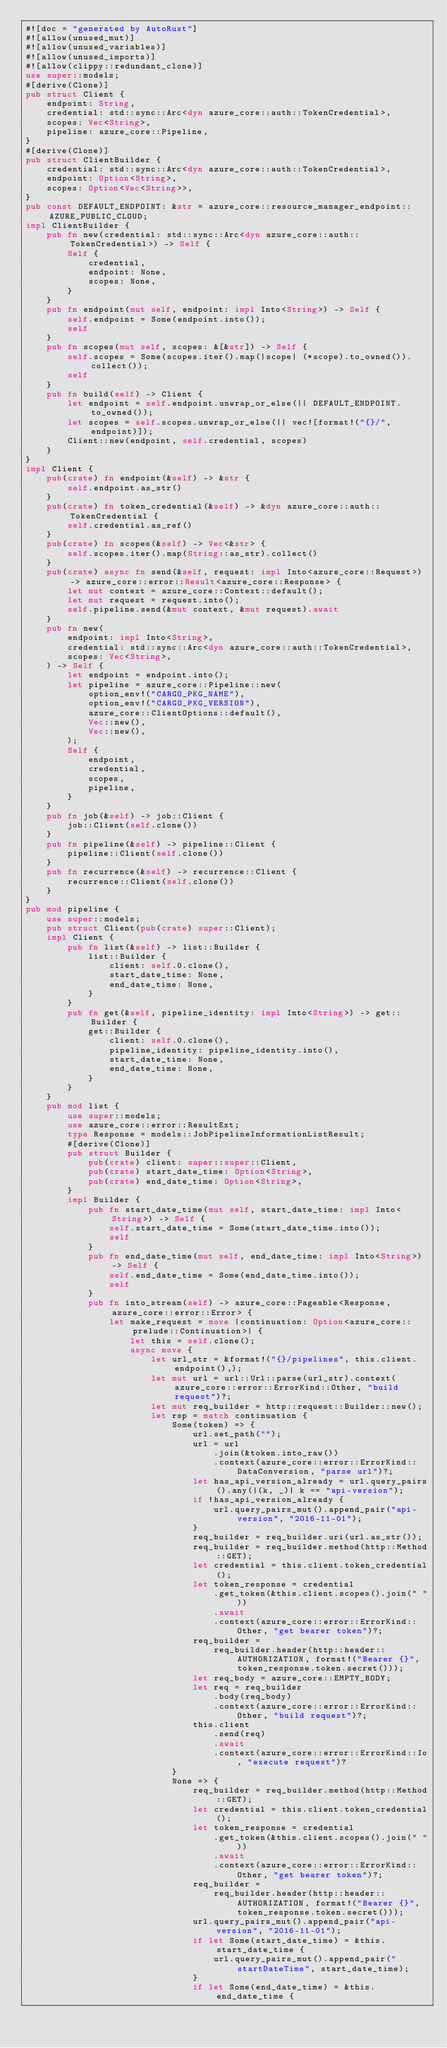<code> <loc_0><loc_0><loc_500><loc_500><_Rust_>#![doc = "generated by AutoRust"]
#![allow(unused_mut)]
#![allow(unused_variables)]
#![allow(unused_imports)]
#![allow(clippy::redundant_clone)]
use super::models;
#[derive(Clone)]
pub struct Client {
    endpoint: String,
    credential: std::sync::Arc<dyn azure_core::auth::TokenCredential>,
    scopes: Vec<String>,
    pipeline: azure_core::Pipeline,
}
#[derive(Clone)]
pub struct ClientBuilder {
    credential: std::sync::Arc<dyn azure_core::auth::TokenCredential>,
    endpoint: Option<String>,
    scopes: Option<Vec<String>>,
}
pub const DEFAULT_ENDPOINT: &str = azure_core::resource_manager_endpoint::AZURE_PUBLIC_CLOUD;
impl ClientBuilder {
    pub fn new(credential: std::sync::Arc<dyn azure_core::auth::TokenCredential>) -> Self {
        Self {
            credential,
            endpoint: None,
            scopes: None,
        }
    }
    pub fn endpoint(mut self, endpoint: impl Into<String>) -> Self {
        self.endpoint = Some(endpoint.into());
        self
    }
    pub fn scopes(mut self, scopes: &[&str]) -> Self {
        self.scopes = Some(scopes.iter().map(|scope| (*scope).to_owned()).collect());
        self
    }
    pub fn build(self) -> Client {
        let endpoint = self.endpoint.unwrap_or_else(|| DEFAULT_ENDPOINT.to_owned());
        let scopes = self.scopes.unwrap_or_else(|| vec![format!("{}/", endpoint)]);
        Client::new(endpoint, self.credential, scopes)
    }
}
impl Client {
    pub(crate) fn endpoint(&self) -> &str {
        self.endpoint.as_str()
    }
    pub(crate) fn token_credential(&self) -> &dyn azure_core::auth::TokenCredential {
        self.credential.as_ref()
    }
    pub(crate) fn scopes(&self) -> Vec<&str> {
        self.scopes.iter().map(String::as_str).collect()
    }
    pub(crate) async fn send(&self, request: impl Into<azure_core::Request>) -> azure_core::error::Result<azure_core::Response> {
        let mut context = azure_core::Context::default();
        let mut request = request.into();
        self.pipeline.send(&mut context, &mut request).await
    }
    pub fn new(
        endpoint: impl Into<String>,
        credential: std::sync::Arc<dyn azure_core::auth::TokenCredential>,
        scopes: Vec<String>,
    ) -> Self {
        let endpoint = endpoint.into();
        let pipeline = azure_core::Pipeline::new(
            option_env!("CARGO_PKG_NAME"),
            option_env!("CARGO_PKG_VERSION"),
            azure_core::ClientOptions::default(),
            Vec::new(),
            Vec::new(),
        );
        Self {
            endpoint,
            credential,
            scopes,
            pipeline,
        }
    }
    pub fn job(&self) -> job::Client {
        job::Client(self.clone())
    }
    pub fn pipeline(&self) -> pipeline::Client {
        pipeline::Client(self.clone())
    }
    pub fn recurrence(&self) -> recurrence::Client {
        recurrence::Client(self.clone())
    }
}
pub mod pipeline {
    use super::models;
    pub struct Client(pub(crate) super::Client);
    impl Client {
        pub fn list(&self) -> list::Builder {
            list::Builder {
                client: self.0.clone(),
                start_date_time: None,
                end_date_time: None,
            }
        }
        pub fn get(&self, pipeline_identity: impl Into<String>) -> get::Builder {
            get::Builder {
                client: self.0.clone(),
                pipeline_identity: pipeline_identity.into(),
                start_date_time: None,
                end_date_time: None,
            }
        }
    }
    pub mod list {
        use super::models;
        use azure_core::error::ResultExt;
        type Response = models::JobPipelineInformationListResult;
        #[derive(Clone)]
        pub struct Builder {
            pub(crate) client: super::super::Client,
            pub(crate) start_date_time: Option<String>,
            pub(crate) end_date_time: Option<String>,
        }
        impl Builder {
            pub fn start_date_time(mut self, start_date_time: impl Into<String>) -> Self {
                self.start_date_time = Some(start_date_time.into());
                self
            }
            pub fn end_date_time(mut self, end_date_time: impl Into<String>) -> Self {
                self.end_date_time = Some(end_date_time.into());
                self
            }
            pub fn into_stream(self) -> azure_core::Pageable<Response, azure_core::error::Error> {
                let make_request = move |continuation: Option<azure_core::prelude::Continuation>| {
                    let this = self.clone();
                    async move {
                        let url_str = &format!("{}/pipelines", this.client.endpoint(),);
                        let mut url = url::Url::parse(url_str).context(azure_core::error::ErrorKind::Other, "build request")?;
                        let mut req_builder = http::request::Builder::new();
                        let rsp = match continuation {
                            Some(token) => {
                                url.set_path("");
                                url = url
                                    .join(&token.into_raw())
                                    .context(azure_core::error::ErrorKind::DataConversion, "parse url")?;
                                let has_api_version_already = url.query_pairs().any(|(k, _)| k == "api-version");
                                if !has_api_version_already {
                                    url.query_pairs_mut().append_pair("api-version", "2016-11-01");
                                }
                                req_builder = req_builder.uri(url.as_str());
                                req_builder = req_builder.method(http::Method::GET);
                                let credential = this.client.token_credential();
                                let token_response = credential
                                    .get_token(&this.client.scopes().join(" "))
                                    .await
                                    .context(azure_core::error::ErrorKind::Other, "get bearer token")?;
                                req_builder =
                                    req_builder.header(http::header::AUTHORIZATION, format!("Bearer {}", token_response.token.secret()));
                                let req_body = azure_core::EMPTY_BODY;
                                let req = req_builder
                                    .body(req_body)
                                    .context(azure_core::error::ErrorKind::Other, "build request")?;
                                this.client
                                    .send(req)
                                    .await
                                    .context(azure_core::error::ErrorKind::Io, "execute request")?
                            }
                            None => {
                                req_builder = req_builder.method(http::Method::GET);
                                let credential = this.client.token_credential();
                                let token_response = credential
                                    .get_token(&this.client.scopes().join(" "))
                                    .await
                                    .context(azure_core::error::ErrorKind::Other, "get bearer token")?;
                                req_builder =
                                    req_builder.header(http::header::AUTHORIZATION, format!("Bearer {}", token_response.token.secret()));
                                url.query_pairs_mut().append_pair("api-version", "2016-11-01");
                                if let Some(start_date_time) = &this.start_date_time {
                                    url.query_pairs_mut().append_pair("startDateTime", start_date_time);
                                }
                                if let Some(end_date_time) = &this.end_date_time {</code> 